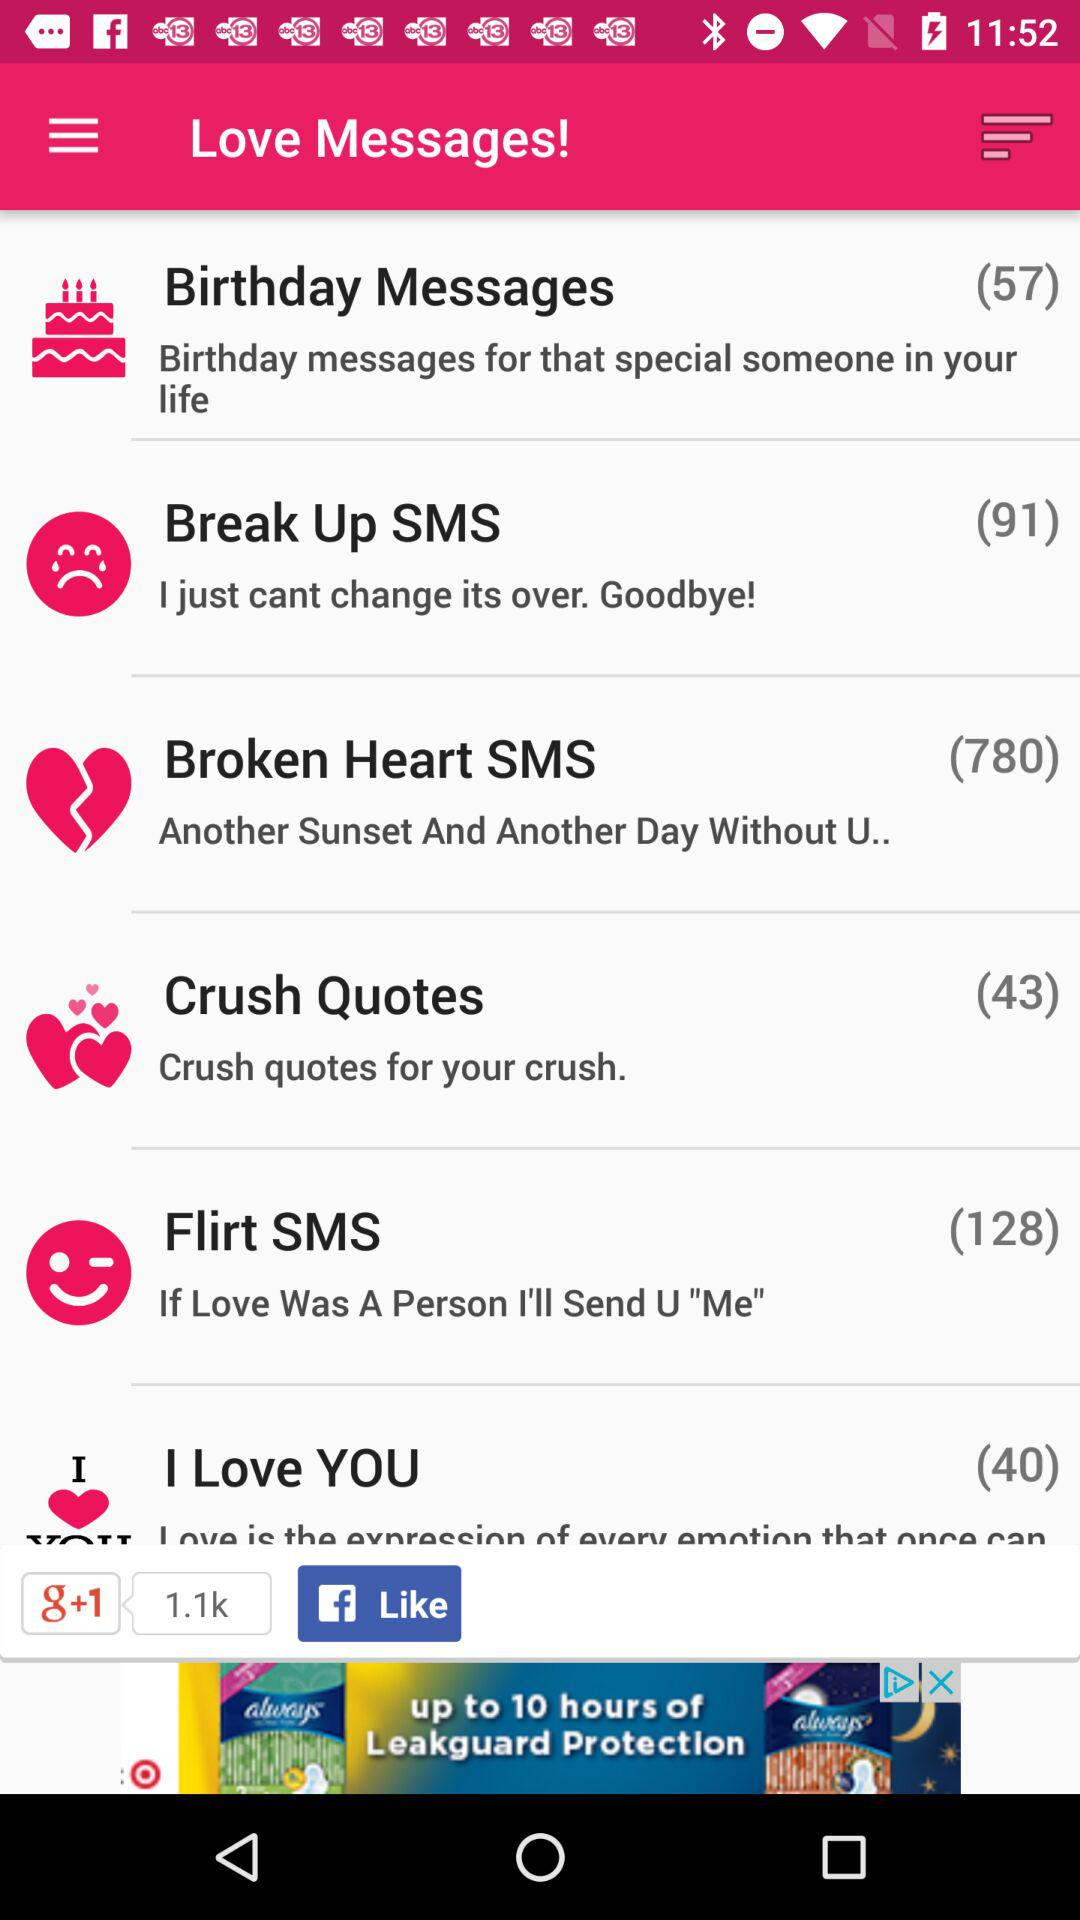How many messages are there in "Flirt SMS"? There are 128 messages in "Flirt SMS". 